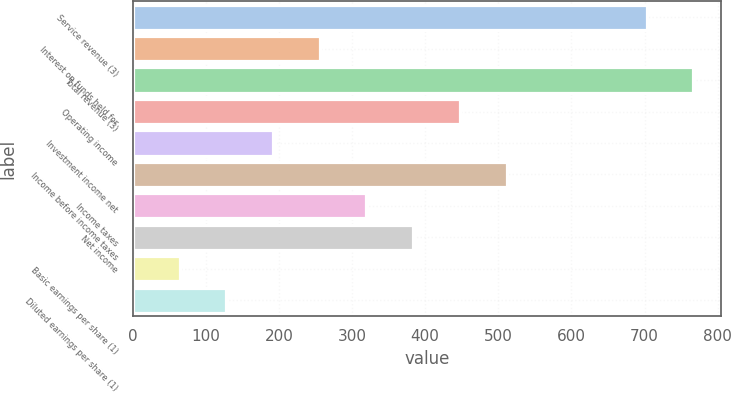<chart> <loc_0><loc_0><loc_500><loc_500><bar_chart><fcel>Service revenue (3)<fcel>Interest on funds held for<fcel>Total revenue (3)<fcel>Operating income<fcel>Investment income net<fcel>Income before income taxes<fcel>Income taxes<fcel>Net income<fcel>Basic earnings per share (1)<fcel>Diluted earnings per share (1)<nl><fcel>702.88<fcel>255.83<fcel>766.75<fcel>447.43<fcel>191.96<fcel>511.3<fcel>319.69<fcel>383.56<fcel>64.22<fcel>128.09<nl></chart> 